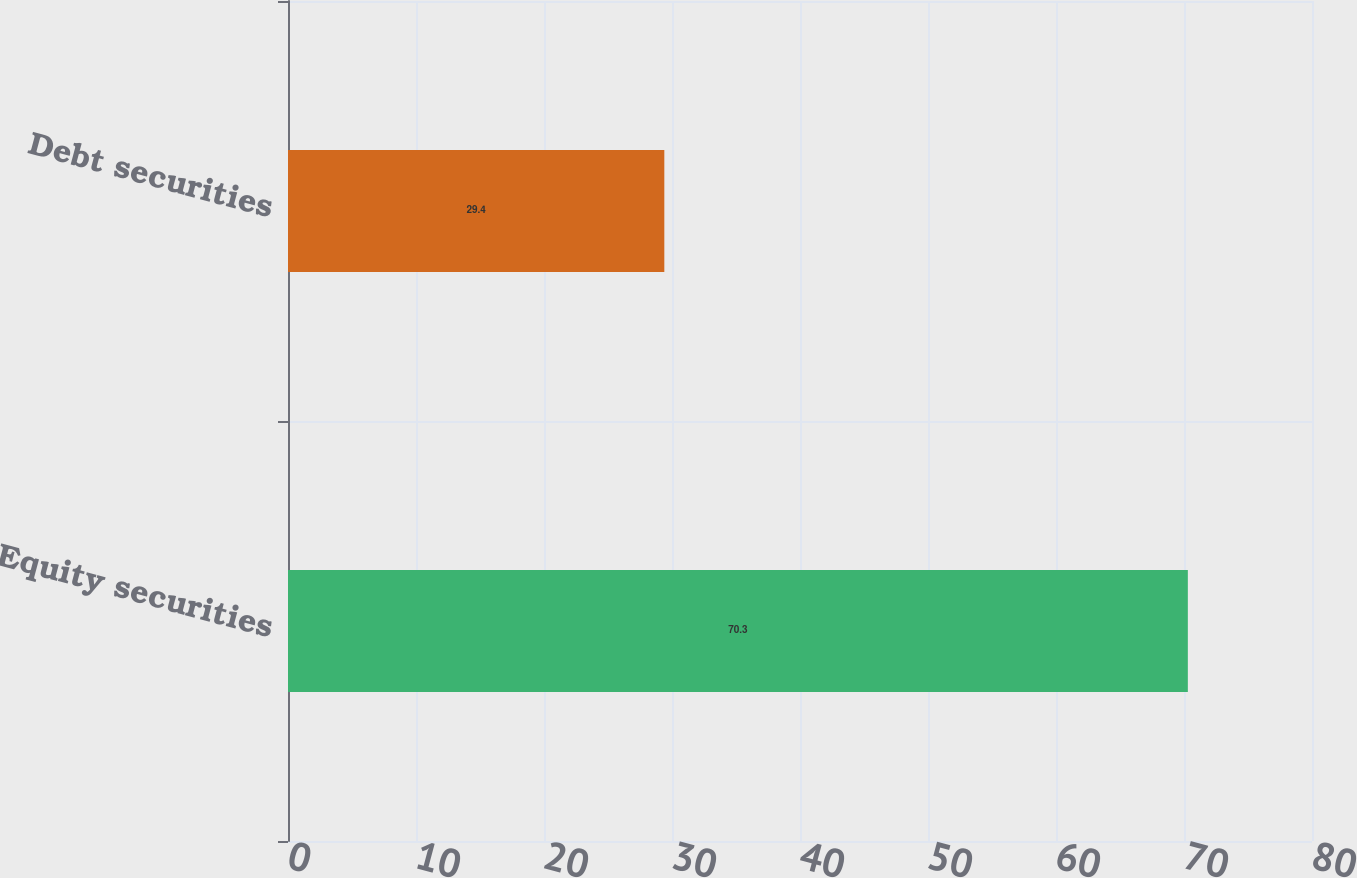<chart> <loc_0><loc_0><loc_500><loc_500><bar_chart><fcel>Equity securities<fcel>Debt securities<nl><fcel>70.3<fcel>29.4<nl></chart> 